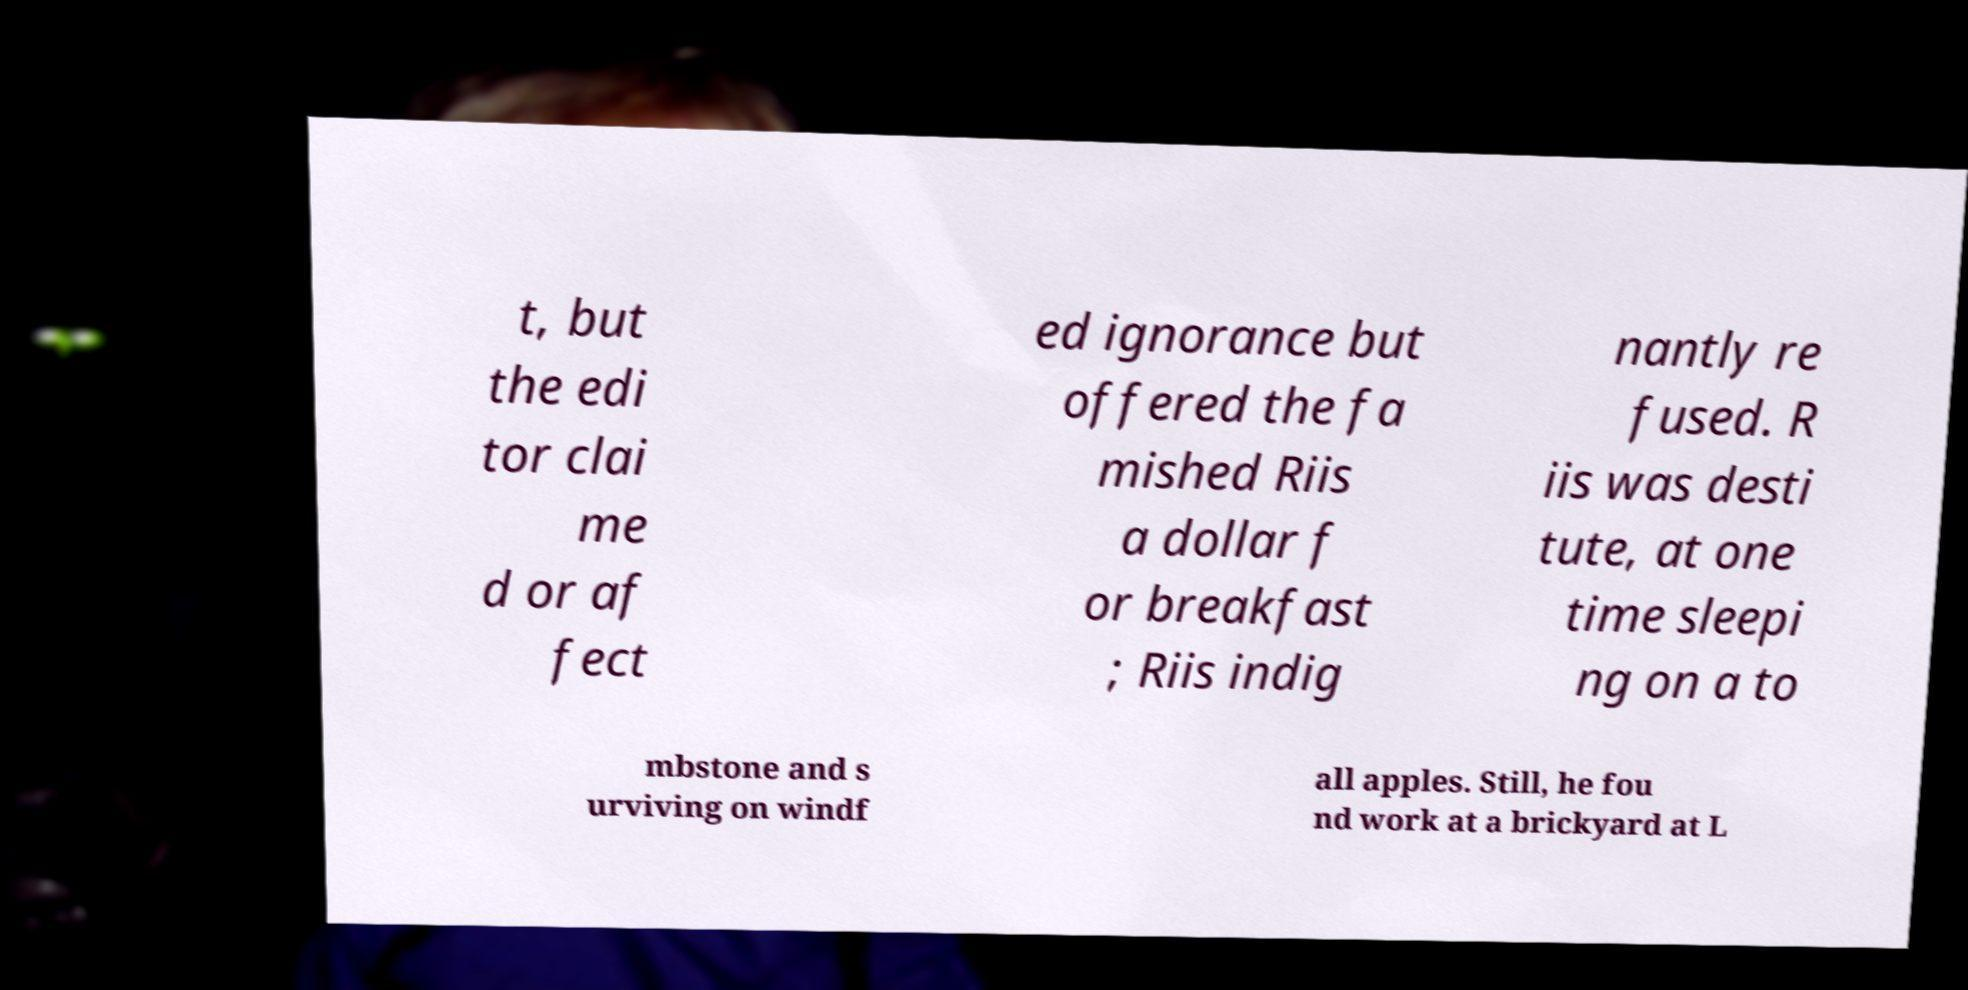What messages or text are displayed in this image? I need them in a readable, typed format. t, but the edi tor clai me d or af fect ed ignorance but offered the fa mished Riis a dollar f or breakfast ; Riis indig nantly re fused. R iis was desti tute, at one time sleepi ng on a to mbstone and s urviving on windf all apples. Still, he fou nd work at a brickyard at L 